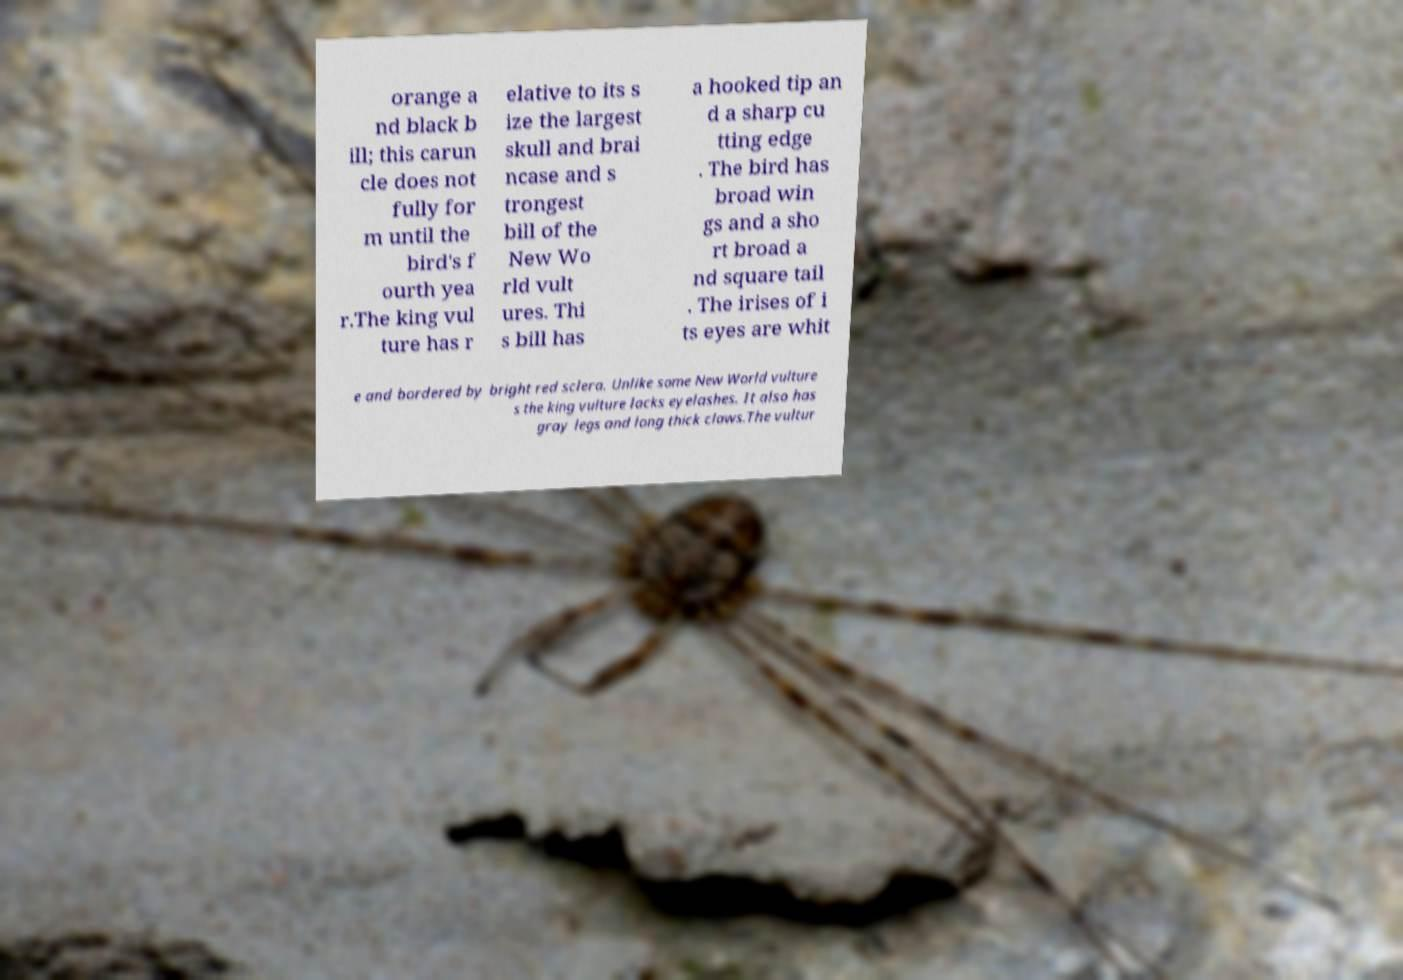Please identify and transcribe the text found in this image. orange a nd black b ill; this carun cle does not fully for m until the bird's f ourth yea r.The king vul ture has r elative to its s ize the largest skull and brai ncase and s trongest bill of the New Wo rld vult ures. Thi s bill has a hooked tip an d a sharp cu tting edge . The bird has broad win gs and a sho rt broad a nd square tail . The irises of i ts eyes are whit e and bordered by bright red sclera. Unlike some New World vulture s the king vulture lacks eyelashes. It also has gray legs and long thick claws.The vultur 